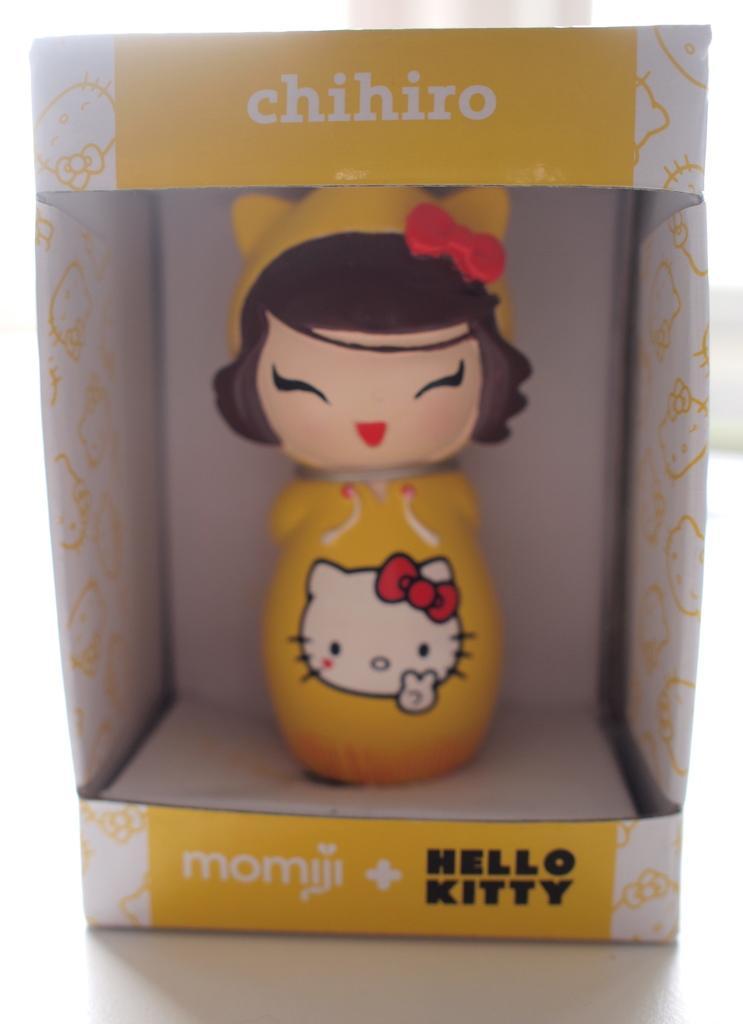How would you summarize this image in a sentence or two? In this image we can see a girl toy in a box which is on the surface. 